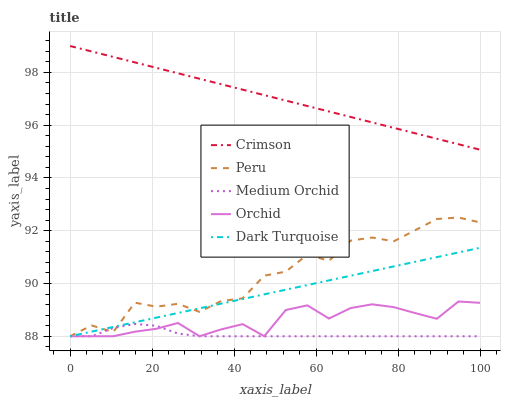Does Dark Turquoise have the minimum area under the curve?
Answer yes or no. No. Does Dark Turquoise have the maximum area under the curve?
Answer yes or no. No. Is Dark Turquoise the smoothest?
Answer yes or no. No. Is Dark Turquoise the roughest?
Answer yes or no. No. Does Dark Turquoise have the highest value?
Answer yes or no. No. Is Peru less than Crimson?
Answer yes or no. Yes. Is Crimson greater than Dark Turquoise?
Answer yes or no. Yes. Does Peru intersect Crimson?
Answer yes or no. No. 